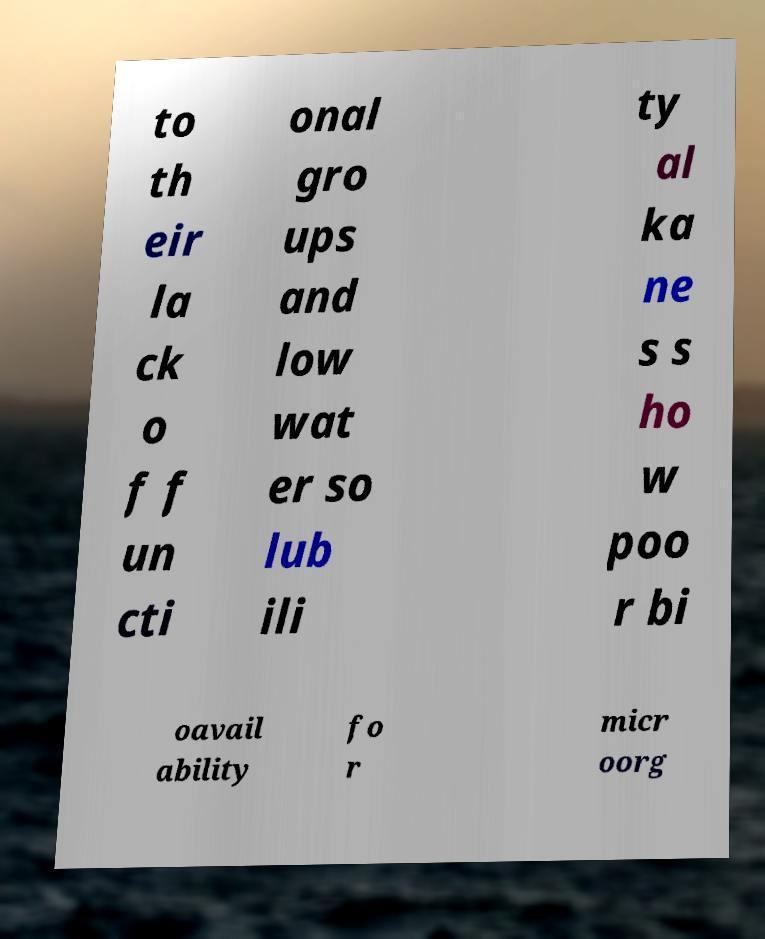Could you assist in decoding the text presented in this image and type it out clearly? to th eir la ck o f f un cti onal gro ups and low wat er so lub ili ty al ka ne s s ho w poo r bi oavail ability fo r micr oorg 